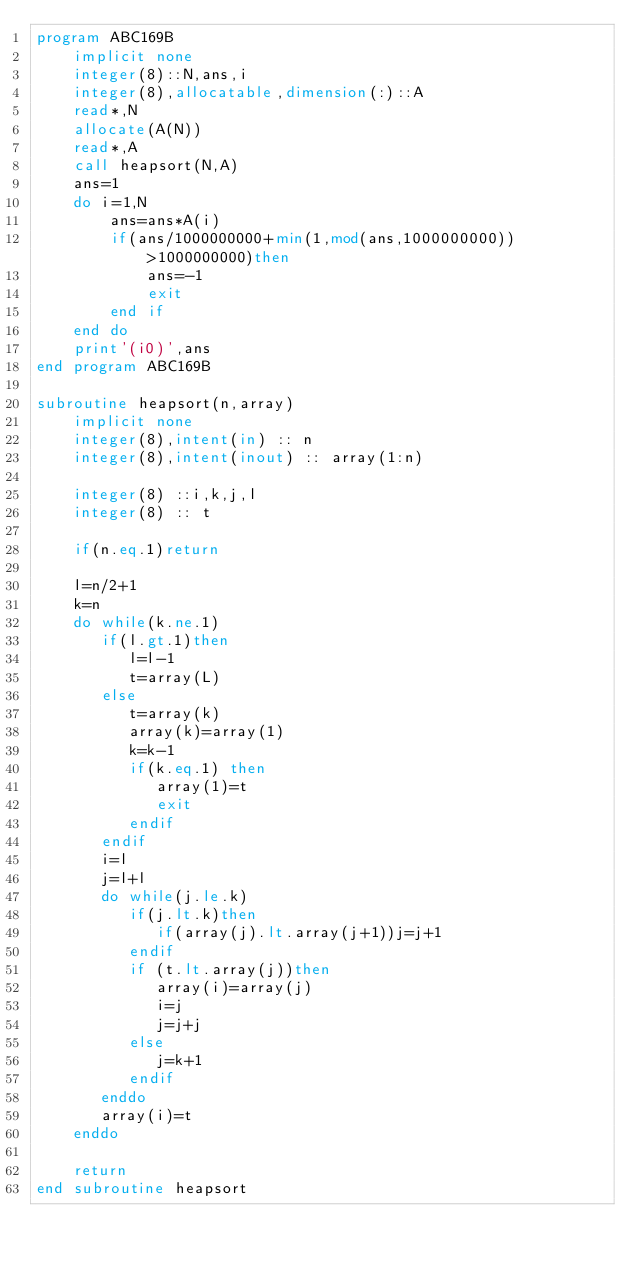Convert code to text. <code><loc_0><loc_0><loc_500><loc_500><_FORTRAN_>program ABC169B
    implicit none
    integer(8)::N,ans,i
    integer(8),allocatable,dimension(:)::A
    read*,N
    allocate(A(N))
    read*,A
    call heapsort(N,A)
    ans=1
    do i=1,N
        ans=ans*A(i)
        if(ans/1000000000+min(1,mod(ans,1000000000))>1000000000)then
            ans=-1
            exit
        end if
    end do
    print'(i0)',ans
end program ABC169B

subroutine heapsort(n,array)
    implicit none
    integer(8),intent(in) :: n
    integer(8),intent(inout) :: array(1:n)
   
    integer(8) ::i,k,j,l
    integer(8) :: t
   
    if(n.eq.1)return
  
    l=n/2+1
    k=n
    do while(k.ne.1)
       if(l.gt.1)then
          l=l-1
          t=array(L)
       else
          t=array(k)
          array(k)=array(1)
          k=k-1
          if(k.eq.1) then
             array(1)=t
             exit
          endif
       endif
       i=l
       j=l+l
       do while(j.le.k)
          if(j.lt.k)then
             if(array(j).lt.array(j+1))j=j+1
          endif
          if (t.lt.array(j))then
             array(i)=array(j)
             i=j
             j=j+j
          else
             j=k+1
          endif
       enddo
       array(i)=t
    enddo
  
    return
end subroutine heapsort</code> 